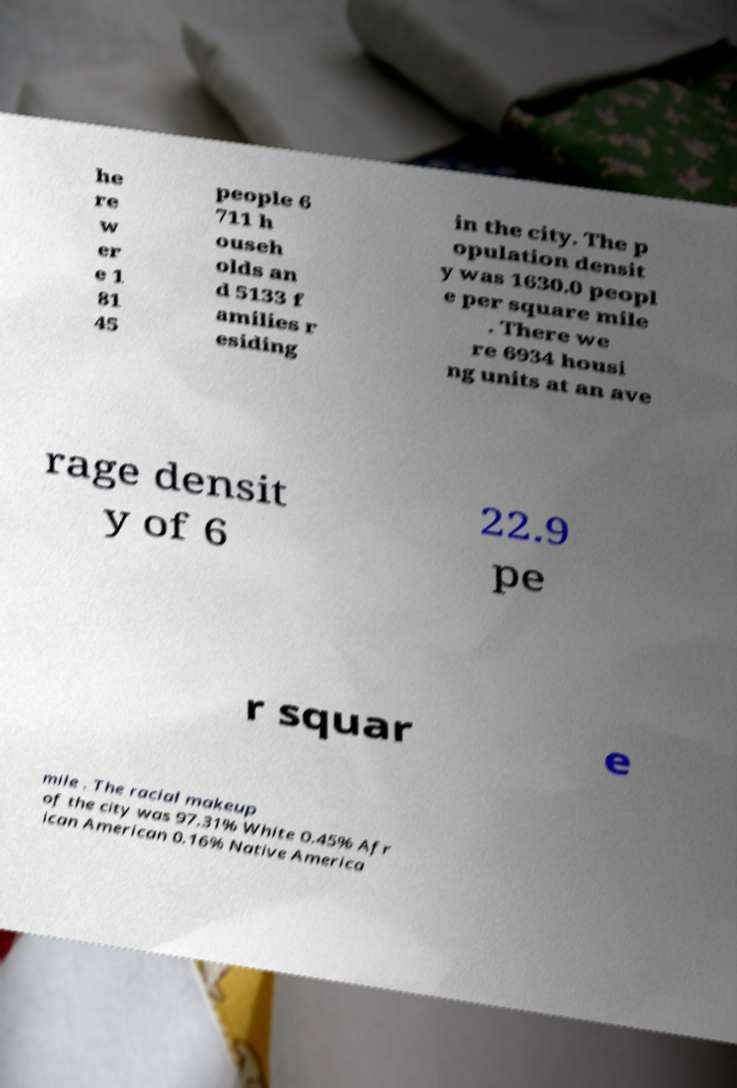Could you extract and type out the text from this image? he re w er e 1 81 45 people 6 711 h ouseh olds an d 5133 f amilies r esiding in the city. The p opulation densit y was 1630.0 peopl e per square mile . There we re 6934 housi ng units at an ave rage densit y of 6 22.9 pe r squar e mile . The racial makeup of the city was 97.31% White 0.45% Afr ican American 0.16% Native America 